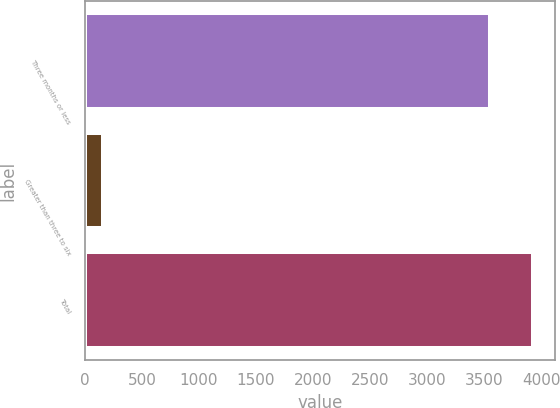<chart> <loc_0><loc_0><loc_500><loc_500><bar_chart><fcel>Three months or less<fcel>Greater than three to six<fcel>Total<nl><fcel>3553<fcel>156<fcel>3926.6<nl></chart> 